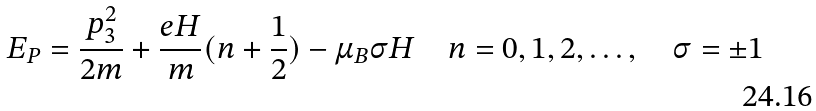<formula> <loc_0><loc_0><loc_500><loc_500>E _ { P } = \frac { p _ { 3 } ^ { 2 } } { 2 m } + \frac { e H } { m } ( n + \frac { 1 } { 2 } ) - \mu _ { B } \sigma H \quad n = 0 , 1 , 2 , \dots , \quad \sigma = \pm 1</formula> 